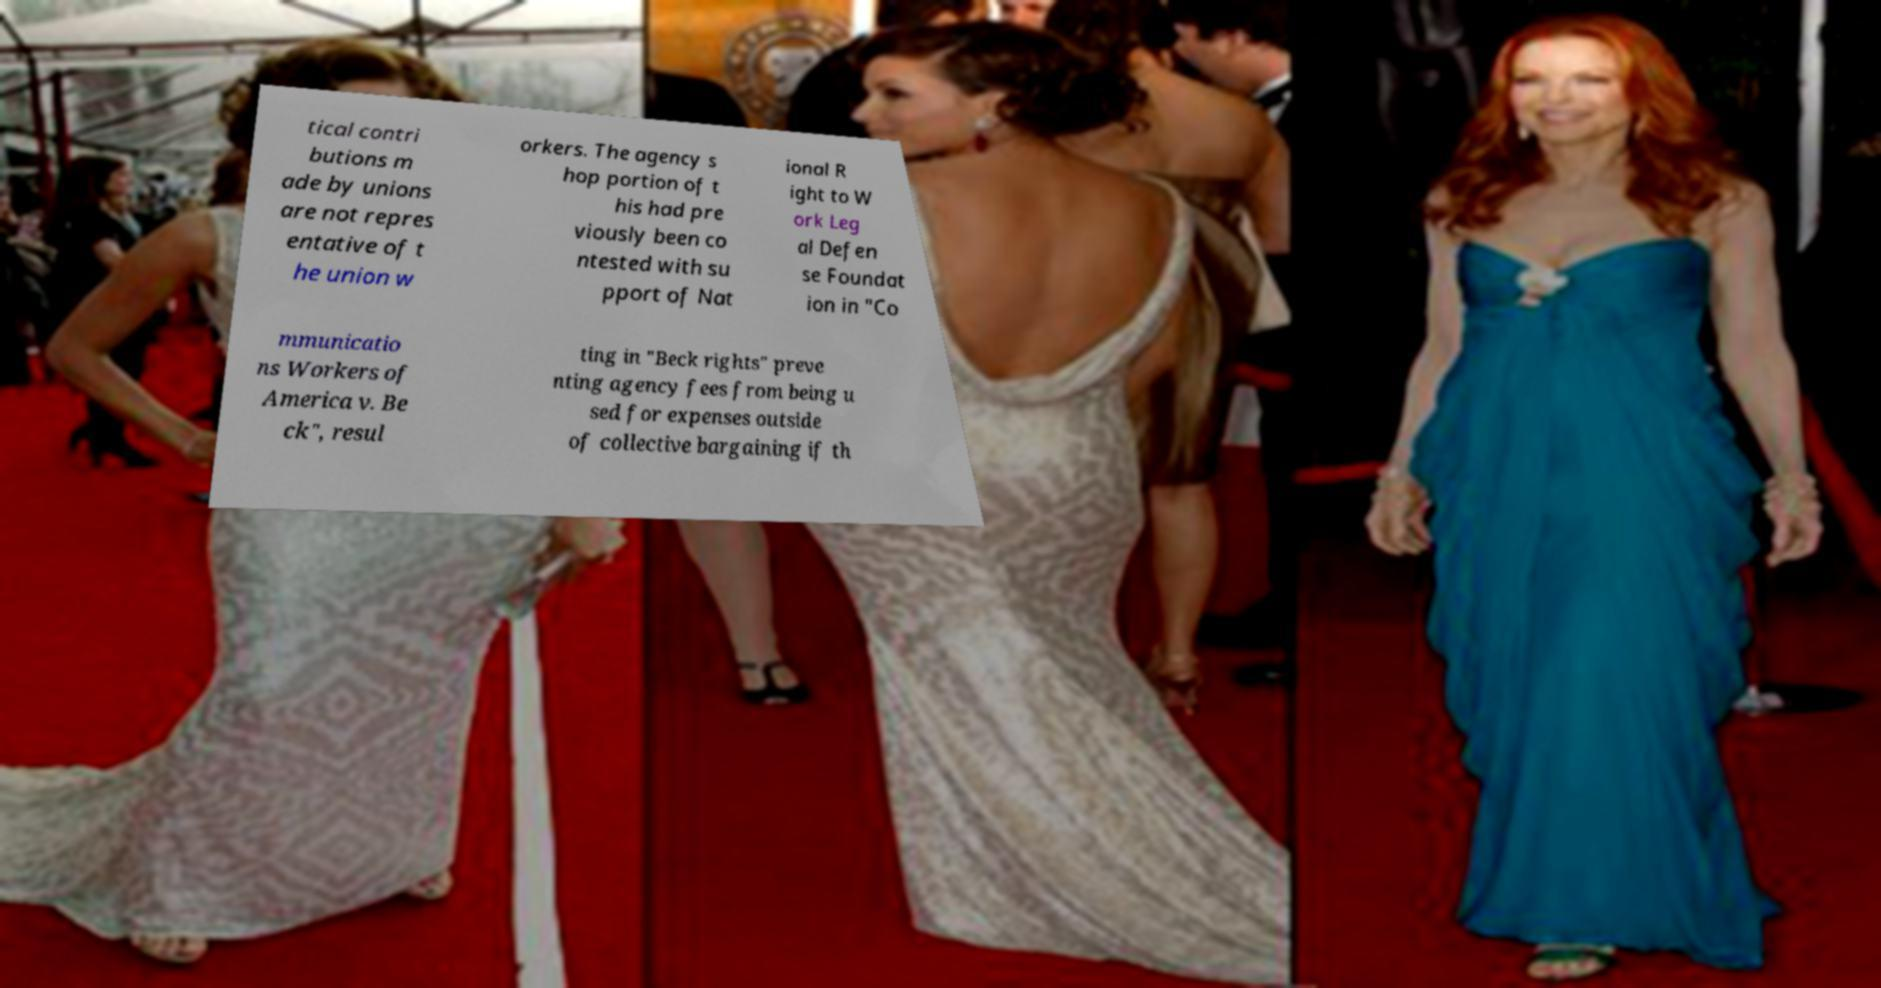Please identify and transcribe the text found in this image. tical contri butions m ade by unions are not repres entative of t he union w orkers. The agency s hop portion of t his had pre viously been co ntested with su pport of Nat ional R ight to W ork Leg al Defen se Foundat ion in "Co mmunicatio ns Workers of America v. Be ck", resul ting in "Beck rights" preve nting agency fees from being u sed for expenses outside of collective bargaining if th 